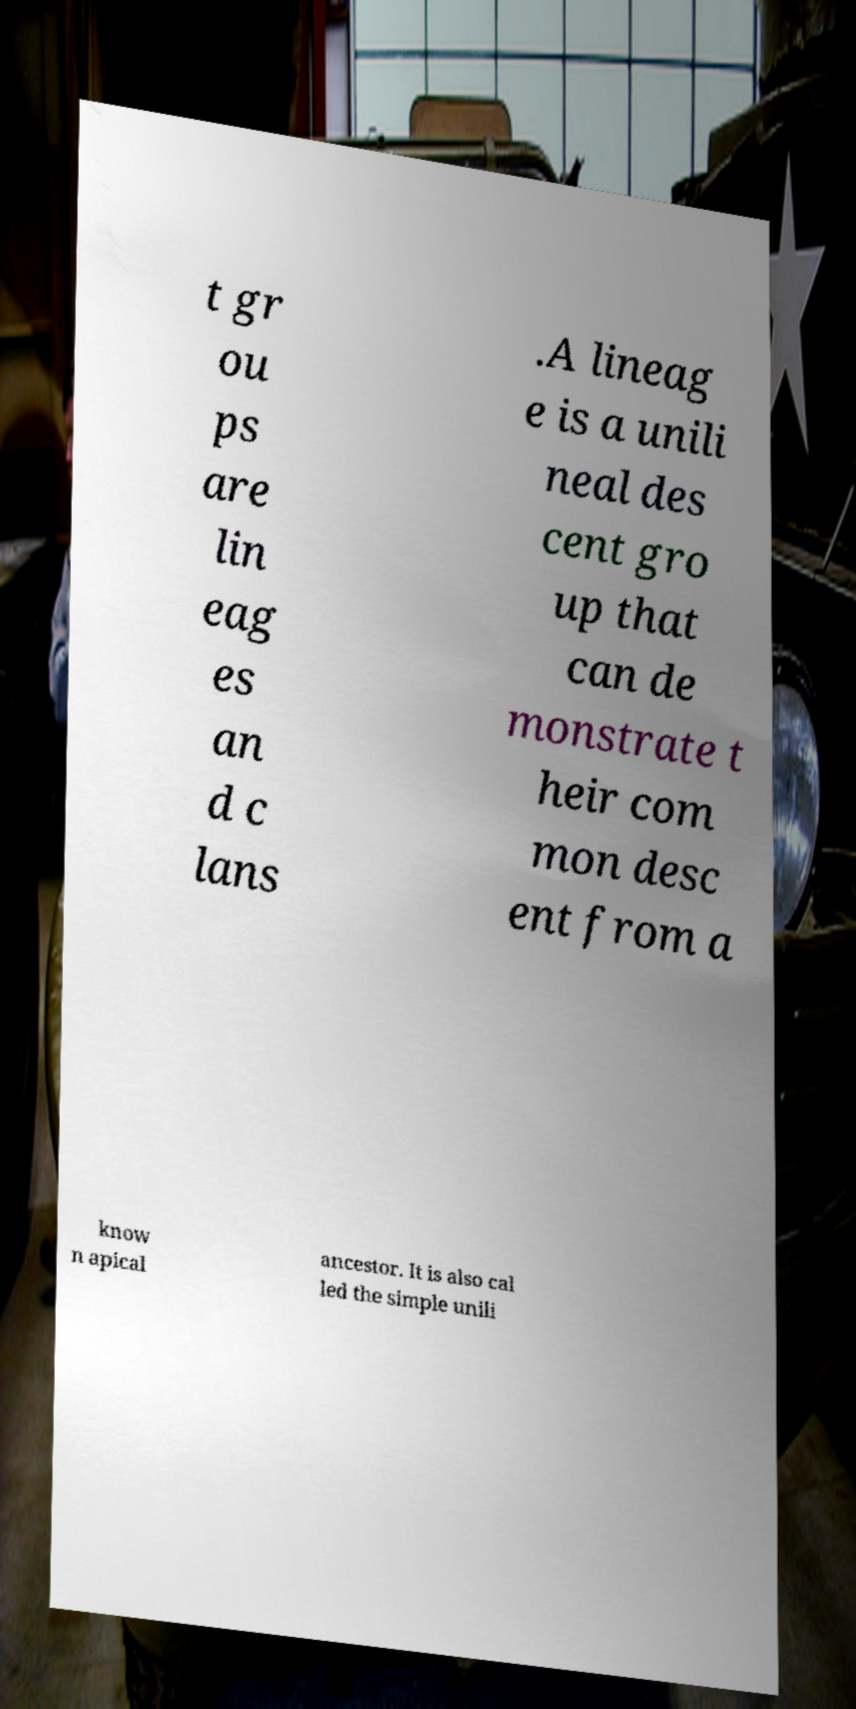For documentation purposes, I need the text within this image transcribed. Could you provide that? t gr ou ps are lin eag es an d c lans .A lineag e is a unili neal des cent gro up that can de monstrate t heir com mon desc ent from a know n apical ancestor. It is also cal led the simple unili 